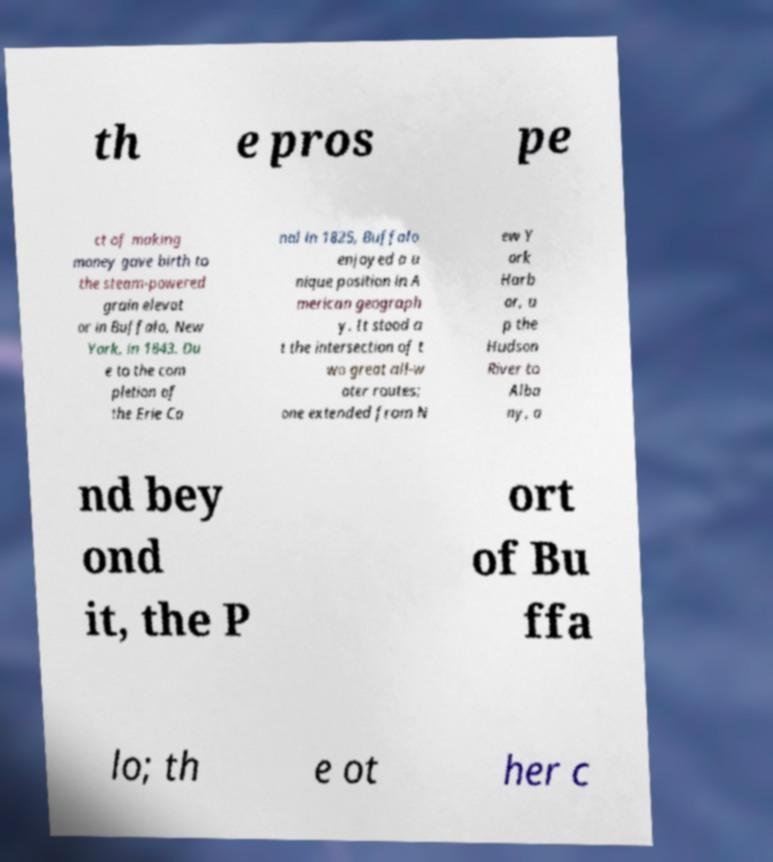I need the written content from this picture converted into text. Can you do that? th e pros pe ct of making money gave birth to the steam-powered grain elevat or in Buffalo, New York, in 1843. Du e to the com pletion of the Erie Ca nal in 1825, Buffalo enjoyed a u nique position in A merican geograph y. It stood a t the intersection of t wo great all-w ater routes; one extended from N ew Y ork Harb or, u p the Hudson River to Alba ny, a nd bey ond it, the P ort of Bu ffa lo; th e ot her c 